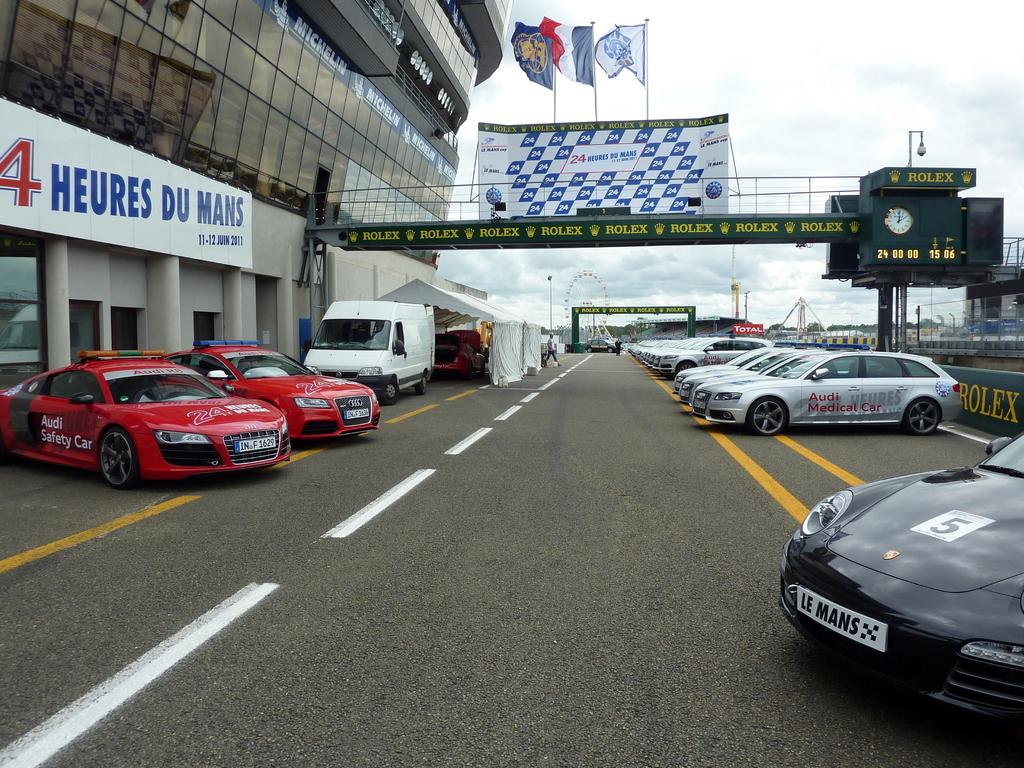What type of vehicles can be seen in the image? There are cars in the image. What is located on the right side of the image? There is a building and banners on the right side of the image. How many quills can be seen on the top of the building in the image? There are no quills present in the image; the building and banners are the only visible items on the right side of the image. 